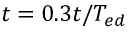<formula> <loc_0><loc_0><loc_500><loc_500>t = 0 . 3 t / T _ { e d }</formula> 